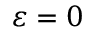<formula> <loc_0><loc_0><loc_500><loc_500>\varepsilon = 0</formula> 